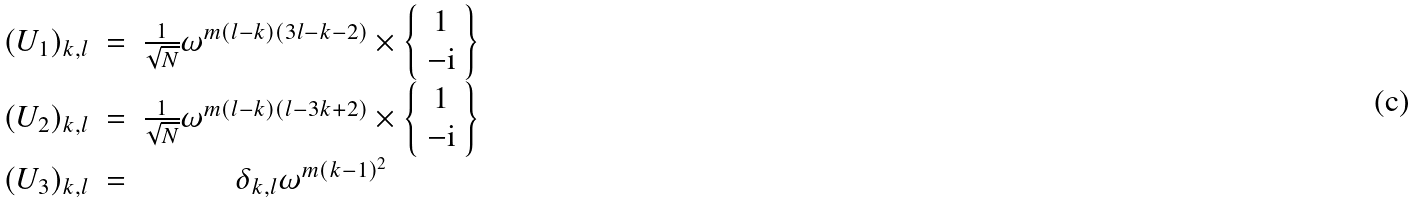Convert formula to latex. <formula><loc_0><loc_0><loc_500><loc_500>\begin{array} { c c c } ( U _ { 1 } ) _ { k , l } & = & \frac { 1 } { \sqrt { N } } \omega ^ { m ( l - k ) ( 3 l - k - 2 ) } \times \left \{ \begin{array} { c } 1 \\ - { \mathrm i } \\ \end{array} \right \} \\ ( U _ { 2 } ) _ { k , l } & = & \frac { 1 } { \sqrt { N } } \omega ^ { m ( l - k ) ( l - 3 k + 2 ) } \times \left \{ \begin{array} { c } 1 \\ - { \mathrm i } \\ \end{array} \right \} \\ ( U _ { 3 } ) _ { k , l } & = & \delta _ { k , l } \omega ^ { m ( k - 1 ) ^ { 2 } } \\ \end{array}</formula> 